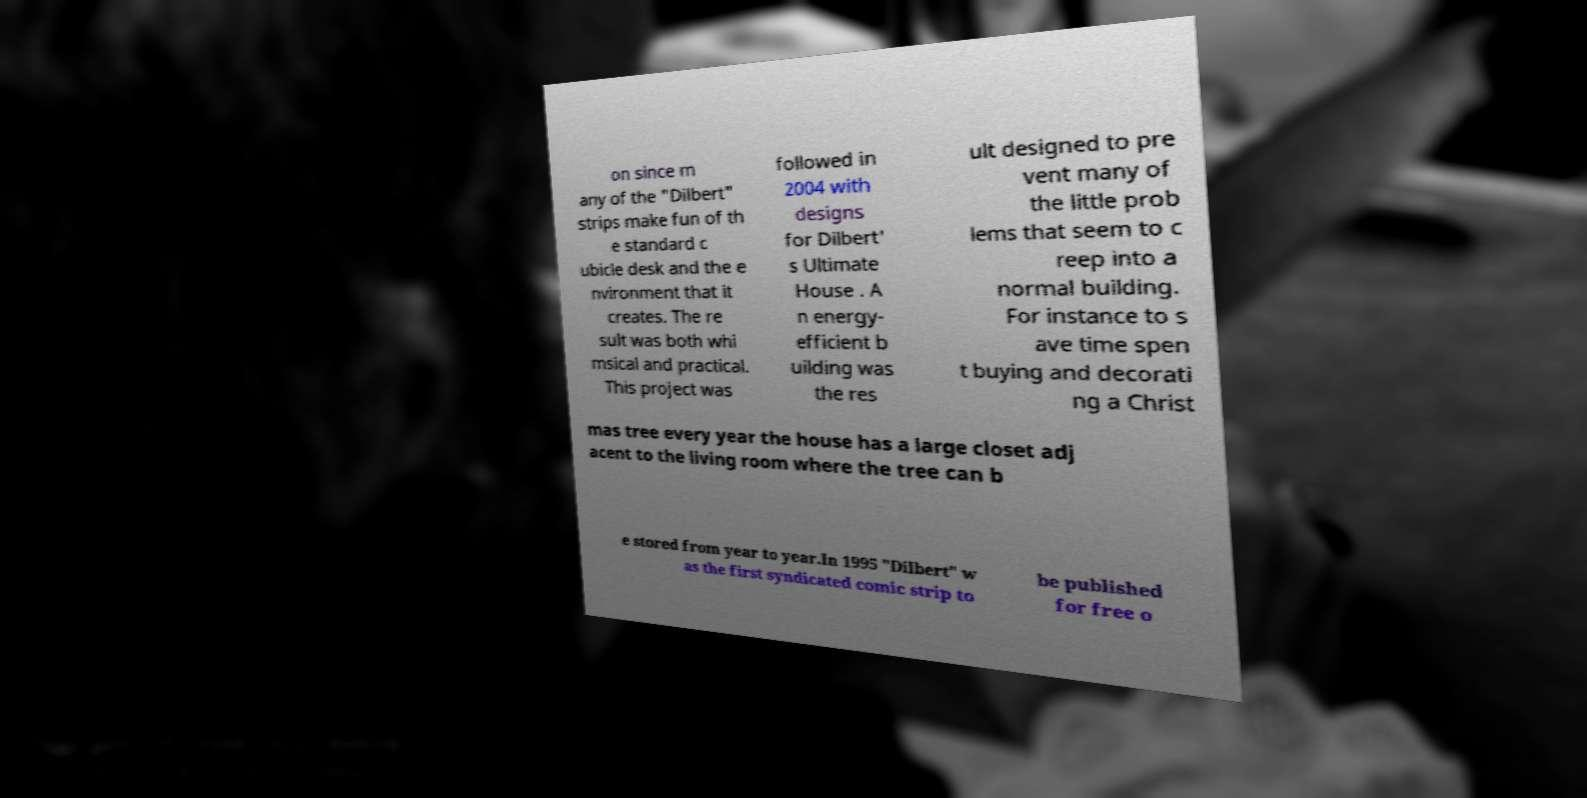Can you read and provide the text displayed in the image?This photo seems to have some interesting text. Can you extract and type it out for me? on since m any of the "Dilbert" strips make fun of th e standard c ubicle desk and the e nvironment that it creates. The re sult was both whi msical and practical. This project was followed in 2004 with designs for Dilbert' s Ultimate House . A n energy- efficient b uilding was the res ult designed to pre vent many of the little prob lems that seem to c reep into a normal building. For instance to s ave time spen t buying and decorati ng a Christ mas tree every year the house has a large closet adj acent to the living room where the tree can b e stored from year to year.In 1995 "Dilbert" w as the first syndicated comic strip to be published for free o 